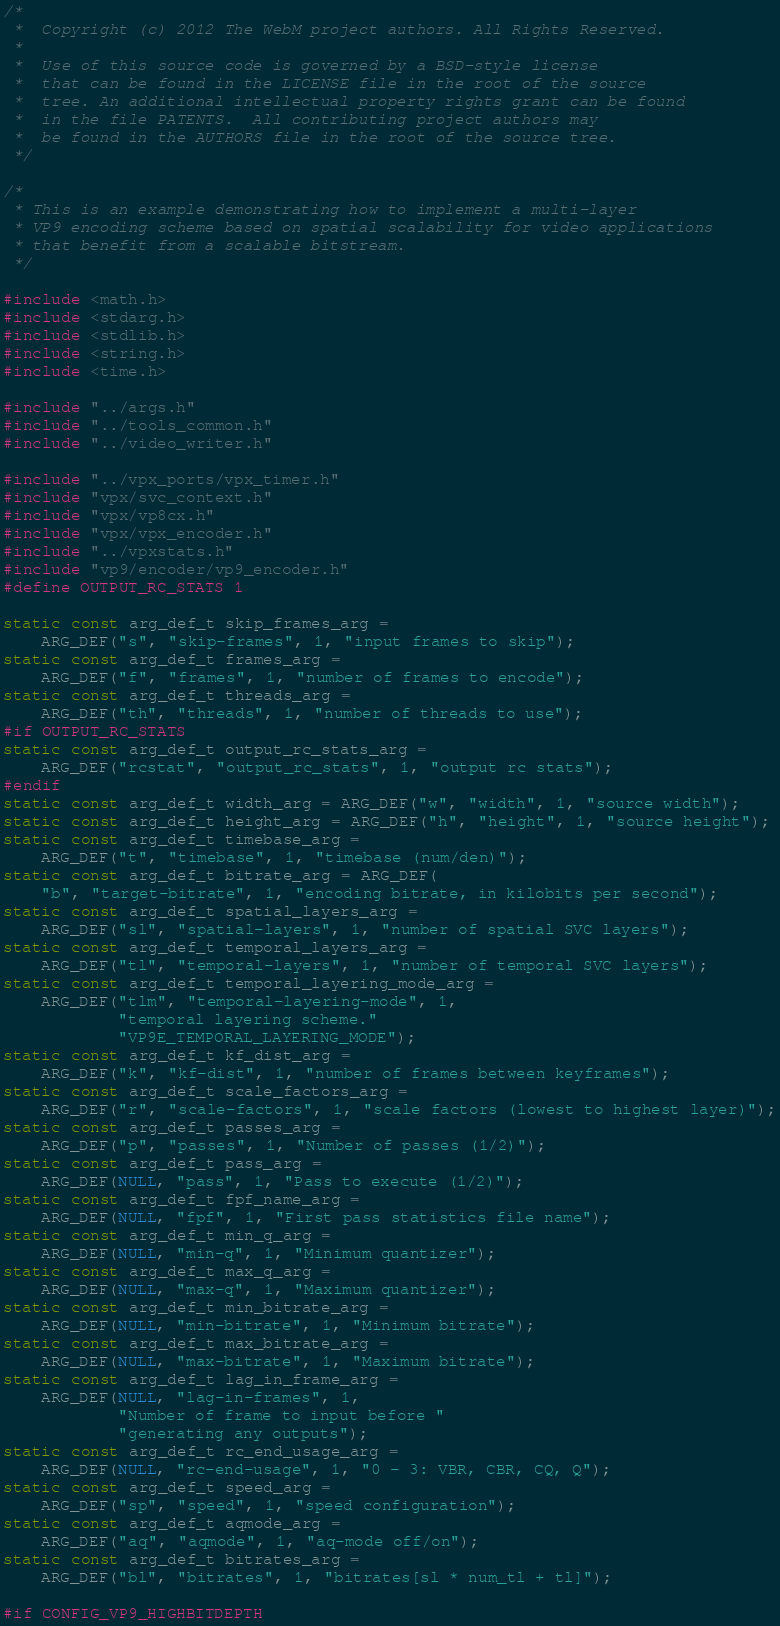Convert code to text. <code><loc_0><loc_0><loc_500><loc_500><_C_>/*
 *  Copyright (c) 2012 The WebM project authors. All Rights Reserved.
 *
 *  Use of this source code is governed by a BSD-style license
 *  that can be found in the LICENSE file in the root of the source
 *  tree. An additional intellectual property rights grant can be found
 *  in the file PATENTS.  All contributing project authors may
 *  be found in the AUTHORS file in the root of the source tree.
 */

/*
 * This is an example demonstrating how to implement a multi-layer
 * VP9 encoding scheme based on spatial scalability for video applications
 * that benefit from a scalable bitstream.
 */

#include <math.h>
#include <stdarg.h>
#include <stdlib.h>
#include <string.h>
#include <time.h>

#include "../args.h"
#include "../tools_common.h"
#include "../video_writer.h"

#include "../vpx_ports/vpx_timer.h"
#include "vpx/svc_context.h"
#include "vpx/vp8cx.h"
#include "vpx/vpx_encoder.h"
#include "../vpxstats.h"
#include "vp9/encoder/vp9_encoder.h"
#define OUTPUT_RC_STATS 1

static const arg_def_t skip_frames_arg =
    ARG_DEF("s", "skip-frames", 1, "input frames to skip");
static const arg_def_t frames_arg =
    ARG_DEF("f", "frames", 1, "number of frames to encode");
static const arg_def_t threads_arg =
    ARG_DEF("th", "threads", 1, "number of threads to use");
#if OUTPUT_RC_STATS
static const arg_def_t output_rc_stats_arg =
    ARG_DEF("rcstat", "output_rc_stats", 1, "output rc stats");
#endif
static const arg_def_t width_arg = ARG_DEF("w", "width", 1, "source width");
static const arg_def_t height_arg = ARG_DEF("h", "height", 1, "source height");
static const arg_def_t timebase_arg =
    ARG_DEF("t", "timebase", 1, "timebase (num/den)");
static const arg_def_t bitrate_arg = ARG_DEF(
    "b", "target-bitrate", 1, "encoding bitrate, in kilobits per second");
static const arg_def_t spatial_layers_arg =
    ARG_DEF("sl", "spatial-layers", 1, "number of spatial SVC layers");
static const arg_def_t temporal_layers_arg =
    ARG_DEF("tl", "temporal-layers", 1, "number of temporal SVC layers");
static const arg_def_t temporal_layering_mode_arg =
    ARG_DEF("tlm", "temporal-layering-mode", 1,
            "temporal layering scheme."
            "VP9E_TEMPORAL_LAYERING_MODE");
static const arg_def_t kf_dist_arg =
    ARG_DEF("k", "kf-dist", 1, "number of frames between keyframes");
static const arg_def_t scale_factors_arg =
    ARG_DEF("r", "scale-factors", 1, "scale factors (lowest to highest layer)");
static const arg_def_t passes_arg =
    ARG_DEF("p", "passes", 1, "Number of passes (1/2)");
static const arg_def_t pass_arg =
    ARG_DEF(NULL, "pass", 1, "Pass to execute (1/2)");
static const arg_def_t fpf_name_arg =
    ARG_DEF(NULL, "fpf", 1, "First pass statistics file name");
static const arg_def_t min_q_arg =
    ARG_DEF(NULL, "min-q", 1, "Minimum quantizer");
static const arg_def_t max_q_arg =
    ARG_DEF(NULL, "max-q", 1, "Maximum quantizer");
static const arg_def_t min_bitrate_arg =
    ARG_DEF(NULL, "min-bitrate", 1, "Minimum bitrate");
static const arg_def_t max_bitrate_arg =
    ARG_DEF(NULL, "max-bitrate", 1, "Maximum bitrate");
static const arg_def_t lag_in_frame_arg =
    ARG_DEF(NULL, "lag-in-frames", 1,
            "Number of frame to input before "
            "generating any outputs");
static const arg_def_t rc_end_usage_arg =
    ARG_DEF(NULL, "rc-end-usage", 1, "0 - 3: VBR, CBR, CQ, Q");
static const arg_def_t speed_arg =
    ARG_DEF("sp", "speed", 1, "speed configuration");
static const arg_def_t aqmode_arg =
    ARG_DEF("aq", "aqmode", 1, "aq-mode off/on");
static const arg_def_t bitrates_arg =
    ARG_DEF("bl", "bitrates", 1, "bitrates[sl * num_tl + tl]");

#if CONFIG_VP9_HIGHBITDEPTH</code> 